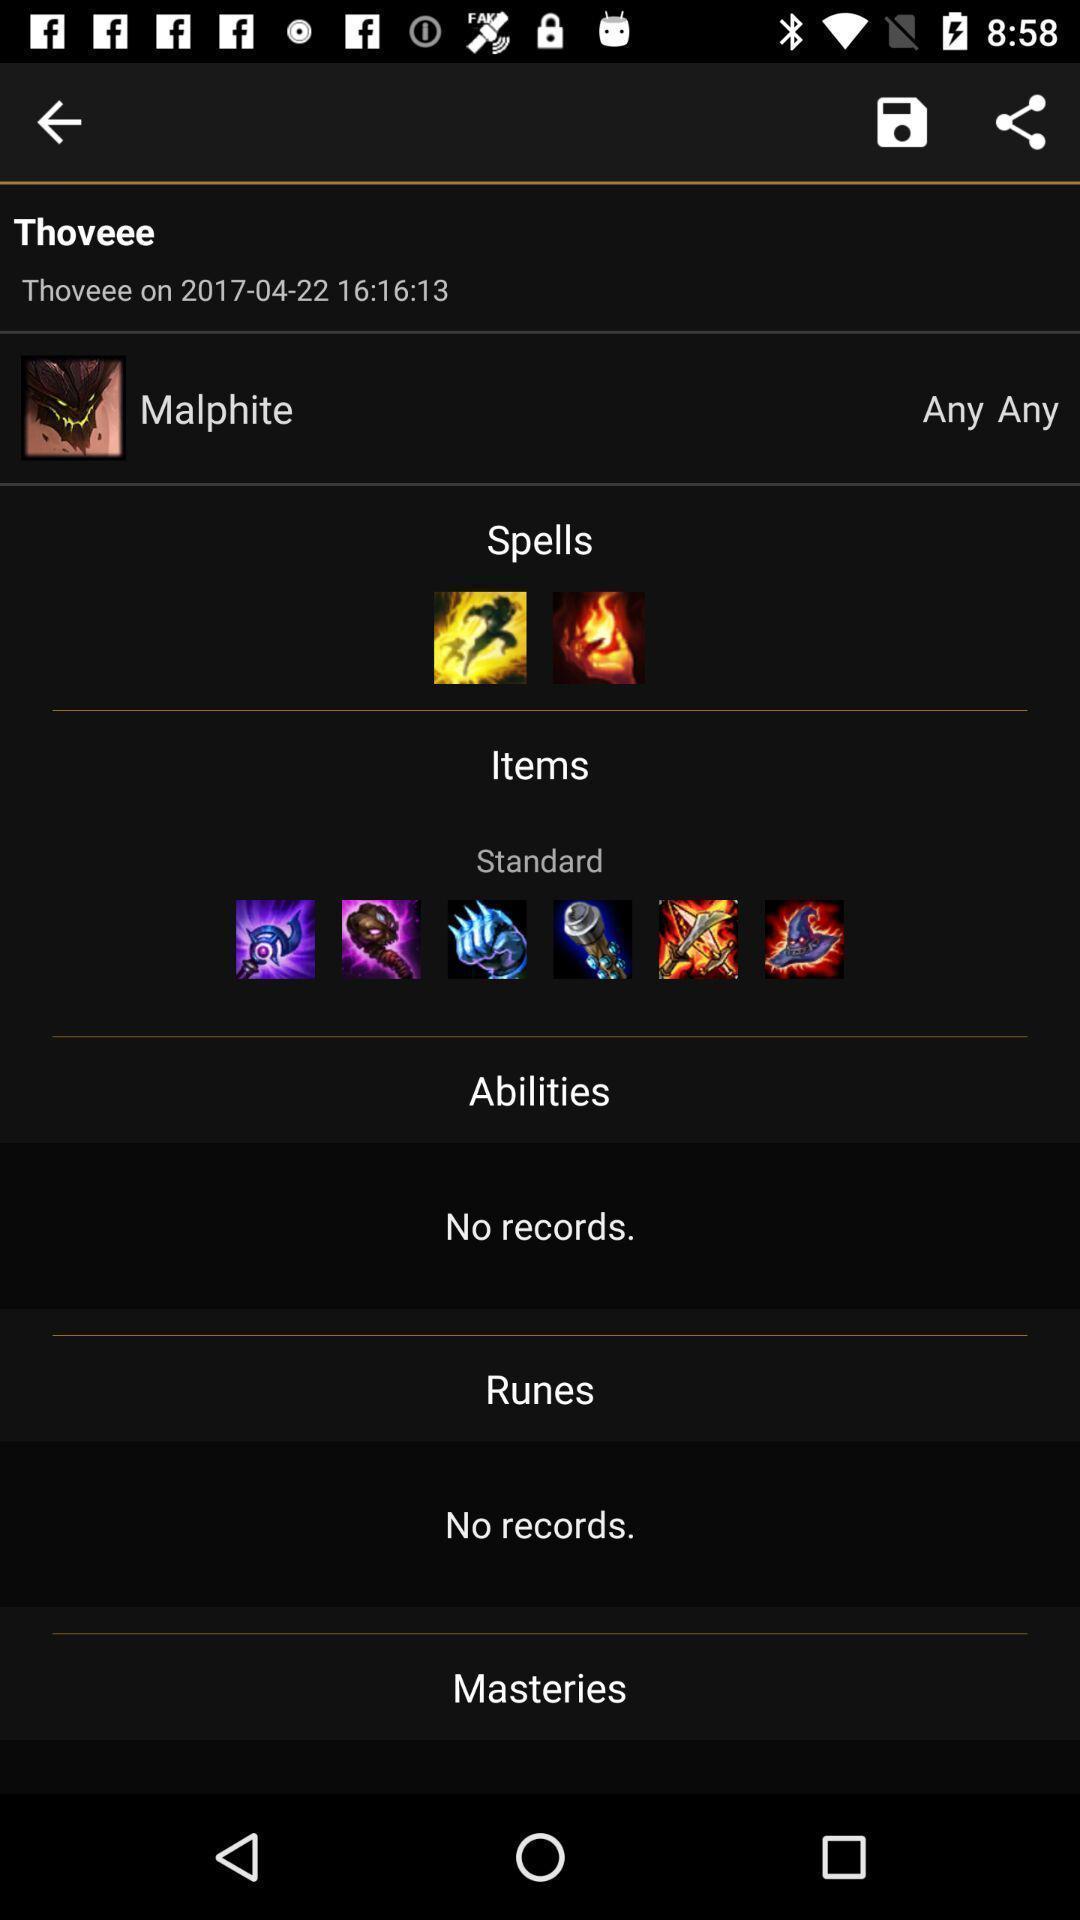Summarize the information in this screenshot. Screen shows multiple options. 